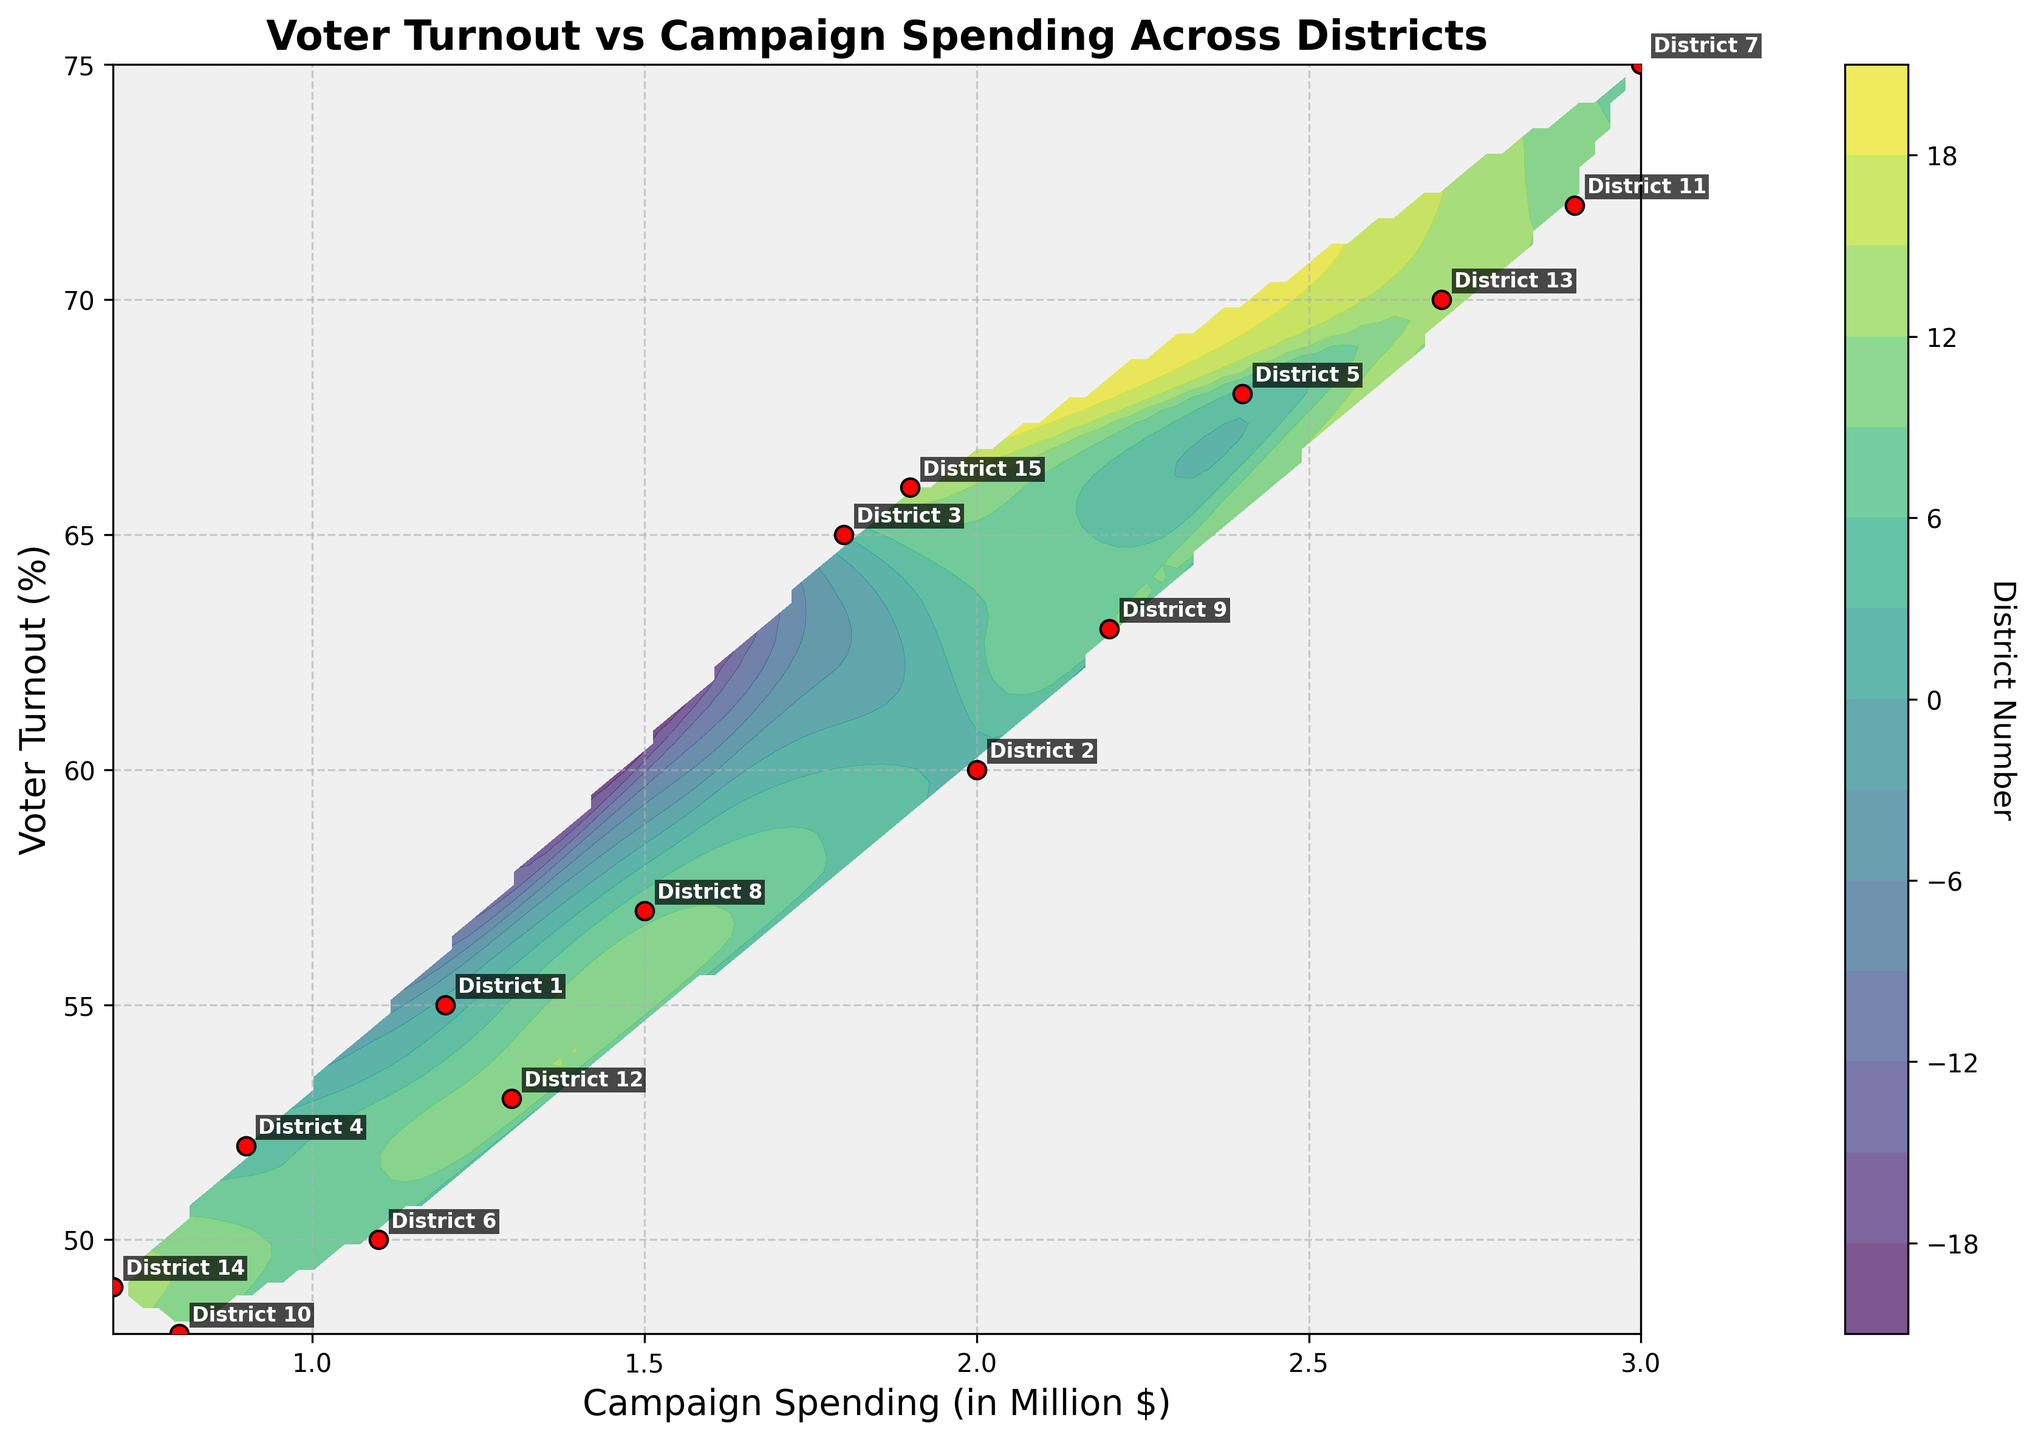what is the title of the plot? The title of the plot is displayed at the top of the figure. By examining the figure, we see the text that describes the plot's main comparison.
Answer: Voter Turnout vs Campaign Spending Across Districts what are the two variables plotted on the axes? The axis labels describe the variables. The x-axis is labeled "Campaign Spending (in Million $)," and the y-axis is labeled "Voter Turnout (%)."
Answer: Campaign Spending and Voter Turnout how many data points are visible in the plot? Each red dot represents a data point, visually identifiable in the scatter plot. Counting these red dots gives us the total number of data points.
Answer: 15 which district had the highest voter turnout? By checking the labeled districts, we can identify the district with the highest y-coordinate. District 7 has the highest voter turnout.
Answer: District 7 what is the range of campaign spending covered in this plot? The range of the x-axis can be observed by looking at the minimum and maximum values displayed on the x-axis. From observation, the minimum campaign spending is 0.7 million, and the maximum is 3.0 million dollars.
Answer: 0.7 to 3.0 million dollars what approximate voter turnout corresponds to 2.0 million dollars in campaign spending? Locating 2.0 on the x-axis and tracing upwards to the closest data point on the y-axis, we observe an approximate voter turnout percentage corresponding to that spending level. This occurs near 60%.
Answer: Approximately 60% which district had the lowest campaign spending? By analyzing the labeled red points, we find the district with the lowest x-coordinate value. District 14 had the lowest campaign spending.
Answer: District 14 is there a visible correlation between higher spending and voter turnout? We observe the general trend of the data points in the plot. A positive correlation would show increasing voter turnout with higher spending, which seems apparent in the overall upward trend.
Answer: Yes what is the voter turnout for district 6? The district is labeled on the plot. By locating "District 6" near its red dot, we find its voter turnout on the y-axis.
Answer: 50% which two districts have a similar voter turnout but differ in campaign spending? Comparing the labeled data points, we find that Districts 2 and 8 have similar voter turnouts around 57-60%, but campaign spending differs at 2.0 and 1.5 million dollars, respectively.
Answer: Districts 2 and 8 